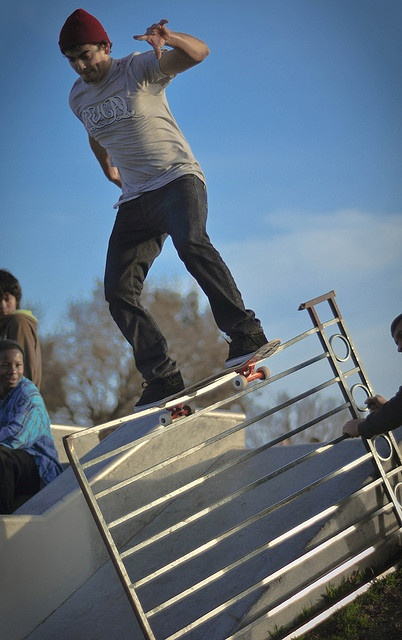Describe the objects in this image and their specific colors. I can see people in blue, black, gray, darkgray, and maroon tones, people in blue, black, teal, navy, and gray tones, people in blue, black, and gray tones, people in blue, black, gray, and darkgray tones, and skateboard in blue, gray, black, and maroon tones in this image. 